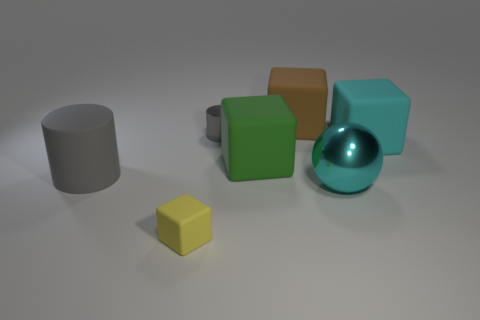How would you describe the texture and material quality of the objects in this image? The objects in the image display a variety of textures. The small yellow cube and the green cube exhibit a matte finish with subtle light absorption, while the brown cube has a slight woodgrain texture, suggesting a natural material. The cyan sphere and the gray cylinder have a high-gloss finish, indicative of a metallic or plastic material, reflecting light and enhancing their curves and cylindrical shape. 